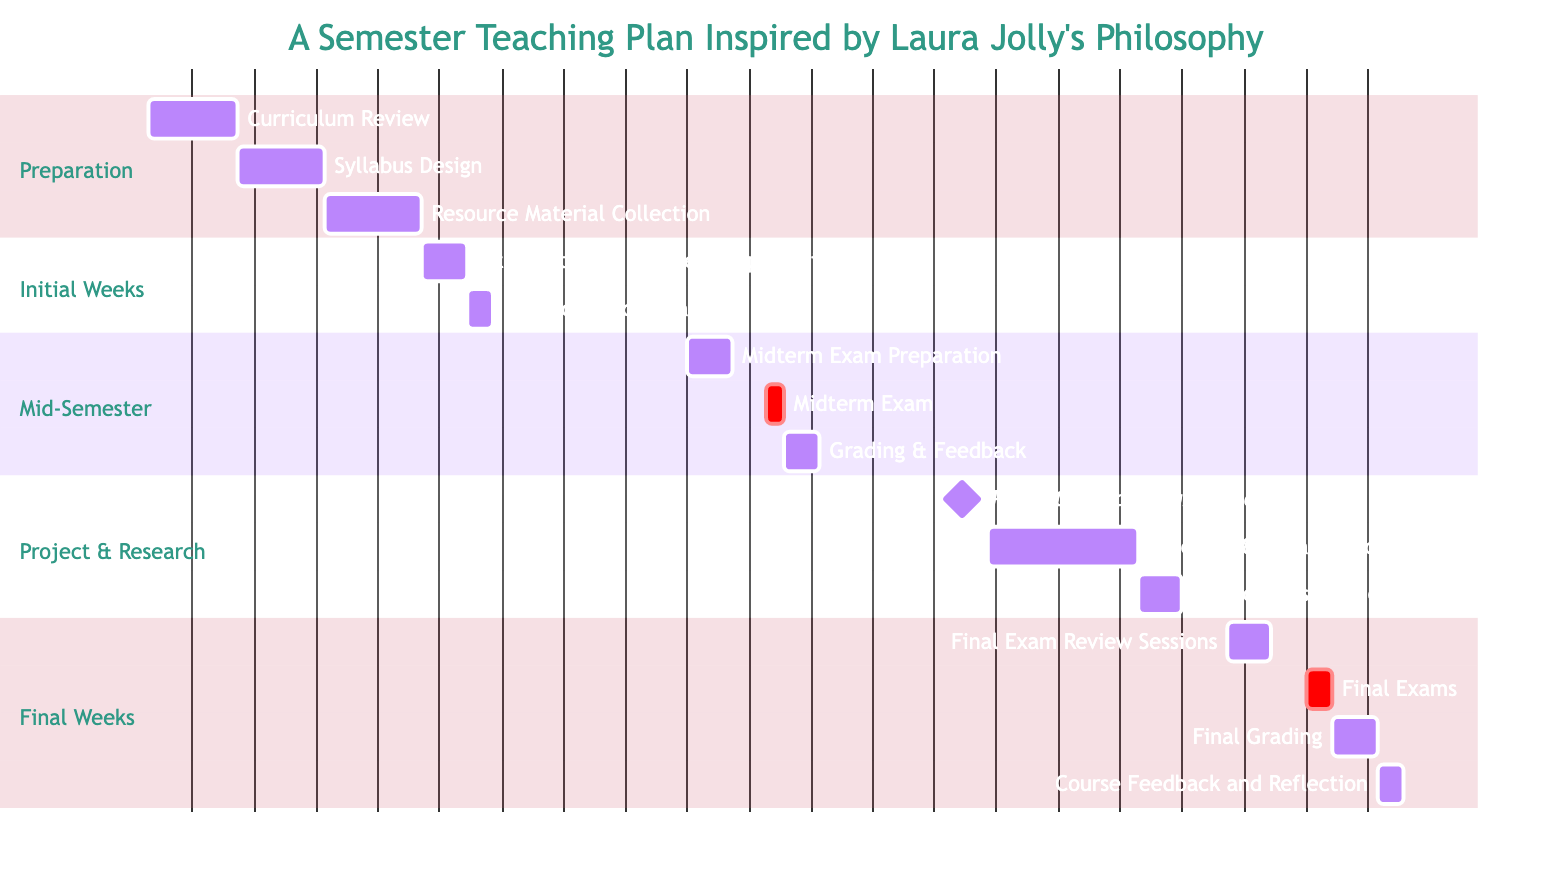What are the start and end dates of the "Project Presentations" task? The "Project Presentations" task starts on November 21, 2023, and ends on November 25, 2023. This information can be gathered directly from the Gantt chart where the task is visually represented with its respective dates.
Answer: November 21, 2023 - November 25, 2023 How many tasks are there in the "Final Weeks" phase? By counting all the tasks presented in the "Final Weeks" section of the Gantt chart, we can identify that there are four tasks: Final Exam Review Sessions, Final Exams, Final Grading, and Course Feedback and Reflection.
Answer: 4 What is the duration of the "Research & Data Collection" task? The "Research & Data Collection" task starts on November 4, 2023, and ends on November 20, 2023. The duration can be calculated by finding the difference between the start and end dates, which is 17 days.
Answer: 17 days Which task overlaps with "Midterm Exam"? "Grading & Feedback" overlaps with "Midterm Exam" as it starts right after the Midterm Exam is completed, specifically on October 12, 2023. The visual representation shows that it follows directly after the "Midterm Exam" task.
Answer: Grading & Feedback What is the total time allocated for the "Initial Weeks" phase? The "Initial Weeks" phase consists of two tasks: "Introduction to Course & Expectations" (5 days) and "Interactive Icebreakers" (3 days). Summing these gives a total of 8 days for this phase, as shown in the Gantt diagram.
Answer: 8 days What task immediately follows "Final Exams"? The task that immediately follows "Final Exams" is "Final Grading", which starts on December 13, 2023, and is visually connected to "Final Exams" in the Gantt chart. This shows the sequence and flow of tasks in that phase.
Answer: Final Grading How many days are scheduled for the "Syllabus Design" task? The "Syllabus Design" task has a scheduled duration of 10 days, starting from August 11, 2023, to August 20, 2023. This is directly observable in the time allocation shown in the Gantt chart for that specific task.
Answer: 10 days What is the milestone in the "Project & Research" phase? The milestone in the "Project & Research" phase is the "Project Proposal Submission", which is designated as a milestone on November 1, 2023, indicating an important point in the timeline without duration indicated.
Answer: Project Proposal Submission 